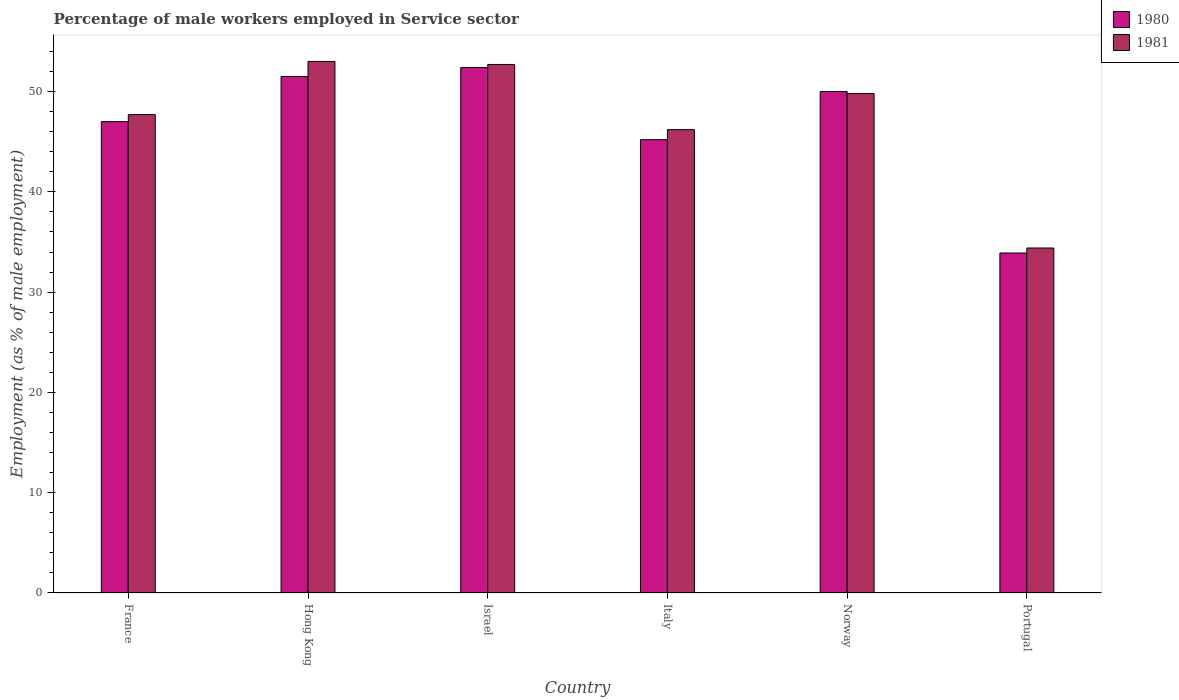How many groups of bars are there?
Your answer should be compact. 6. Are the number of bars per tick equal to the number of legend labels?
Your answer should be compact. Yes. Are the number of bars on each tick of the X-axis equal?
Your answer should be compact. Yes. What is the label of the 5th group of bars from the left?
Ensure brevity in your answer.  Norway. What is the percentage of male workers employed in Service sector in 1980 in Israel?
Ensure brevity in your answer.  52.4. Across all countries, what is the maximum percentage of male workers employed in Service sector in 1980?
Make the answer very short. 52.4. Across all countries, what is the minimum percentage of male workers employed in Service sector in 1981?
Provide a succinct answer. 34.4. In which country was the percentage of male workers employed in Service sector in 1981 maximum?
Offer a very short reply. Hong Kong. What is the total percentage of male workers employed in Service sector in 1980 in the graph?
Give a very brief answer. 280. What is the difference between the percentage of male workers employed in Service sector in 1981 in Hong Kong and that in Norway?
Provide a succinct answer. 3.2. What is the difference between the percentage of male workers employed in Service sector in 1981 in Hong Kong and the percentage of male workers employed in Service sector in 1980 in Italy?
Your answer should be compact. 7.8. What is the average percentage of male workers employed in Service sector in 1980 per country?
Ensure brevity in your answer.  46.67. What is the difference between the percentage of male workers employed in Service sector of/in 1981 and percentage of male workers employed in Service sector of/in 1980 in Israel?
Offer a terse response. 0.3. In how many countries, is the percentage of male workers employed in Service sector in 1981 greater than 40 %?
Offer a very short reply. 5. What is the ratio of the percentage of male workers employed in Service sector in 1981 in France to that in Italy?
Give a very brief answer. 1.03. Is the difference between the percentage of male workers employed in Service sector in 1981 in Italy and Norway greater than the difference between the percentage of male workers employed in Service sector in 1980 in Italy and Norway?
Your answer should be very brief. Yes. What is the difference between the highest and the lowest percentage of male workers employed in Service sector in 1980?
Keep it short and to the point. 18.5. Is the sum of the percentage of male workers employed in Service sector in 1980 in France and Hong Kong greater than the maximum percentage of male workers employed in Service sector in 1981 across all countries?
Your response must be concise. Yes. Are the values on the major ticks of Y-axis written in scientific E-notation?
Ensure brevity in your answer.  No. Does the graph contain grids?
Give a very brief answer. No. How many legend labels are there?
Ensure brevity in your answer.  2. What is the title of the graph?
Give a very brief answer. Percentage of male workers employed in Service sector. What is the label or title of the X-axis?
Ensure brevity in your answer.  Country. What is the label or title of the Y-axis?
Make the answer very short. Employment (as % of male employment). What is the Employment (as % of male employment) of 1980 in France?
Make the answer very short. 47. What is the Employment (as % of male employment) of 1981 in France?
Provide a succinct answer. 47.7. What is the Employment (as % of male employment) of 1980 in Hong Kong?
Ensure brevity in your answer.  51.5. What is the Employment (as % of male employment) of 1981 in Hong Kong?
Give a very brief answer. 53. What is the Employment (as % of male employment) of 1980 in Israel?
Offer a very short reply. 52.4. What is the Employment (as % of male employment) of 1981 in Israel?
Your answer should be very brief. 52.7. What is the Employment (as % of male employment) in 1980 in Italy?
Give a very brief answer. 45.2. What is the Employment (as % of male employment) in 1981 in Italy?
Make the answer very short. 46.2. What is the Employment (as % of male employment) of 1981 in Norway?
Your answer should be very brief. 49.8. What is the Employment (as % of male employment) in 1980 in Portugal?
Your answer should be compact. 33.9. What is the Employment (as % of male employment) of 1981 in Portugal?
Your response must be concise. 34.4. Across all countries, what is the maximum Employment (as % of male employment) in 1980?
Offer a very short reply. 52.4. Across all countries, what is the maximum Employment (as % of male employment) of 1981?
Your answer should be compact. 53. Across all countries, what is the minimum Employment (as % of male employment) of 1980?
Ensure brevity in your answer.  33.9. Across all countries, what is the minimum Employment (as % of male employment) in 1981?
Offer a terse response. 34.4. What is the total Employment (as % of male employment) of 1980 in the graph?
Keep it short and to the point. 280. What is the total Employment (as % of male employment) of 1981 in the graph?
Your response must be concise. 283.8. What is the difference between the Employment (as % of male employment) in 1981 in France and that in Israel?
Your response must be concise. -5. What is the difference between the Employment (as % of male employment) of 1981 in France and that in Italy?
Provide a short and direct response. 1.5. What is the difference between the Employment (as % of male employment) in 1981 in France and that in Norway?
Offer a very short reply. -2.1. What is the difference between the Employment (as % of male employment) in 1980 in Hong Kong and that in Israel?
Ensure brevity in your answer.  -0.9. What is the difference between the Employment (as % of male employment) in 1981 in Hong Kong and that in Israel?
Keep it short and to the point. 0.3. What is the difference between the Employment (as % of male employment) of 1980 in Hong Kong and that in Italy?
Offer a very short reply. 6.3. What is the difference between the Employment (as % of male employment) of 1980 in Hong Kong and that in Norway?
Your response must be concise. 1.5. What is the difference between the Employment (as % of male employment) in 1981 in Hong Kong and that in Norway?
Offer a very short reply. 3.2. What is the difference between the Employment (as % of male employment) of 1981 in Hong Kong and that in Portugal?
Provide a succinct answer. 18.6. What is the difference between the Employment (as % of male employment) of 1980 in Israel and that in Italy?
Keep it short and to the point. 7.2. What is the difference between the Employment (as % of male employment) in 1981 in Israel and that in Italy?
Give a very brief answer. 6.5. What is the difference between the Employment (as % of male employment) in 1980 in Israel and that in Norway?
Your response must be concise. 2.4. What is the difference between the Employment (as % of male employment) of 1980 in Israel and that in Portugal?
Provide a short and direct response. 18.5. What is the difference between the Employment (as % of male employment) of 1980 in Italy and that in Norway?
Ensure brevity in your answer.  -4.8. What is the difference between the Employment (as % of male employment) in 1981 in Italy and that in Norway?
Your answer should be very brief. -3.6. What is the difference between the Employment (as % of male employment) in 1981 in Italy and that in Portugal?
Give a very brief answer. 11.8. What is the difference between the Employment (as % of male employment) of 1980 in Norway and that in Portugal?
Provide a succinct answer. 16.1. What is the difference between the Employment (as % of male employment) in 1980 in France and the Employment (as % of male employment) in 1981 in Hong Kong?
Make the answer very short. -6. What is the difference between the Employment (as % of male employment) of 1980 in France and the Employment (as % of male employment) of 1981 in Israel?
Ensure brevity in your answer.  -5.7. What is the difference between the Employment (as % of male employment) of 1980 in France and the Employment (as % of male employment) of 1981 in Italy?
Provide a succinct answer. 0.8. What is the difference between the Employment (as % of male employment) in 1980 in France and the Employment (as % of male employment) in 1981 in Norway?
Your answer should be compact. -2.8. What is the difference between the Employment (as % of male employment) of 1980 in Hong Kong and the Employment (as % of male employment) of 1981 in Portugal?
Offer a very short reply. 17.1. What is the difference between the Employment (as % of male employment) in 1980 in Israel and the Employment (as % of male employment) in 1981 in Italy?
Provide a short and direct response. 6.2. What is the difference between the Employment (as % of male employment) in 1980 in Israel and the Employment (as % of male employment) in 1981 in Norway?
Your answer should be very brief. 2.6. What is the difference between the Employment (as % of male employment) in 1980 in Israel and the Employment (as % of male employment) in 1981 in Portugal?
Offer a very short reply. 18. What is the difference between the Employment (as % of male employment) of 1980 in Italy and the Employment (as % of male employment) of 1981 in Norway?
Make the answer very short. -4.6. What is the difference between the Employment (as % of male employment) of 1980 in Norway and the Employment (as % of male employment) of 1981 in Portugal?
Give a very brief answer. 15.6. What is the average Employment (as % of male employment) in 1980 per country?
Offer a terse response. 46.67. What is the average Employment (as % of male employment) of 1981 per country?
Provide a short and direct response. 47.3. What is the difference between the Employment (as % of male employment) in 1980 and Employment (as % of male employment) in 1981 in Hong Kong?
Give a very brief answer. -1.5. What is the difference between the Employment (as % of male employment) of 1980 and Employment (as % of male employment) of 1981 in Israel?
Your answer should be very brief. -0.3. What is the difference between the Employment (as % of male employment) in 1980 and Employment (as % of male employment) in 1981 in Italy?
Offer a very short reply. -1. What is the ratio of the Employment (as % of male employment) in 1980 in France to that in Hong Kong?
Ensure brevity in your answer.  0.91. What is the ratio of the Employment (as % of male employment) of 1980 in France to that in Israel?
Offer a terse response. 0.9. What is the ratio of the Employment (as % of male employment) in 1981 in France to that in Israel?
Your answer should be compact. 0.91. What is the ratio of the Employment (as % of male employment) of 1980 in France to that in Italy?
Ensure brevity in your answer.  1.04. What is the ratio of the Employment (as % of male employment) of 1981 in France to that in Italy?
Provide a succinct answer. 1.03. What is the ratio of the Employment (as % of male employment) of 1981 in France to that in Norway?
Keep it short and to the point. 0.96. What is the ratio of the Employment (as % of male employment) of 1980 in France to that in Portugal?
Your answer should be compact. 1.39. What is the ratio of the Employment (as % of male employment) of 1981 in France to that in Portugal?
Give a very brief answer. 1.39. What is the ratio of the Employment (as % of male employment) in 1980 in Hong Kong to that in Israel?
Offer a very short reply. 0.98. What is the ratio of the Employment (as % of male employment) of 1980 in Hong Kong to that in Italy?
Your response must be concise. 1.14. What is the ratio of the Employment (as % of male employment) of 1981 in Hong Kong to that in Italy?
Keep it short and to the point. 1.15. What is the ratio of the Employment (as % of male employment) of 1981 in Hong Kong to that in Norway?
Your answer should be very brief. 1.06. What is the ratio of the Employment (as % of male employment) in 1980 in Hong Kong to that in Portugal?
Your answer should be compact. 1.52. What is the ratio of the Employment (as % of male employment) of 1981 in Hong Kong to that in Portugal?
Make the answer very short. 1.54. What is the ratio of the Employment (as % of male employment) in 1980 in Israel to that in Italy?
Your answer should be compact. 1.16. What is the ratio of the Employment (as % of male employment) of 1981 in Israel to that in Italy?
Ensure brevity in your answer.  1.14. What is the ratio of the Employment (as % of male employment) in 1980 in Israel to that in Norway?
Keep it short and to the point. 1.05. What is the ratio of the Employment (as % of male employment) in 1981 in Israel to that in Norway?
Give a very brief answer. 1.06. What is the ratio of the Employment (as % of male employment) in 1980 in Israel to that in Portugal?
Give a very brief answer. 1.55. What is the ratio of the Employment (as % of male employment) in 1981 in Israel to that in Portugal?
Keep it short and to the point. 1.53. What is the ratio of the Employment (as % of male employment) in 1980 in Italy to that in Norway?
Make the answer very short. 0.9. What is the ratio of the Employment (as % of male employment) in 1981 in Italy to that in Norway?
Give a very brief answer. 0.93. What is the ratio of the Employment (as % of male employment) in 1980 in Italy to that in Portugal?
Offer a very short reply. 1.33. What is the ratio of the Employment (as % of male employment) of 1981 in Italy to that in Portugal?
Ensure brevity in your answer.  1.34. What is the ratio of the Employment (as % of male employment) of 1980 in Norway to that in Portugal?
Provide a short and direct response. 1.47. What is the ratio of the Employment (as % of male employment) of 1981 in Norway to that in Portugal?
Provide a succinct answer. 1.45. 